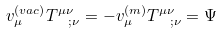Convert formula to latex. <formula><loc_0><loc_0><loc_500><loc_500>v _ { \mu } ^ { \left ( v a c \right ) } T _ { \ \ ; \nu } ^ { \mu \nu } = - v _ { \mu } ^ { \left ( m \right ) } T _ { \ \ ; \nu } ^ { \mu \nu } = \Psi</formula> 